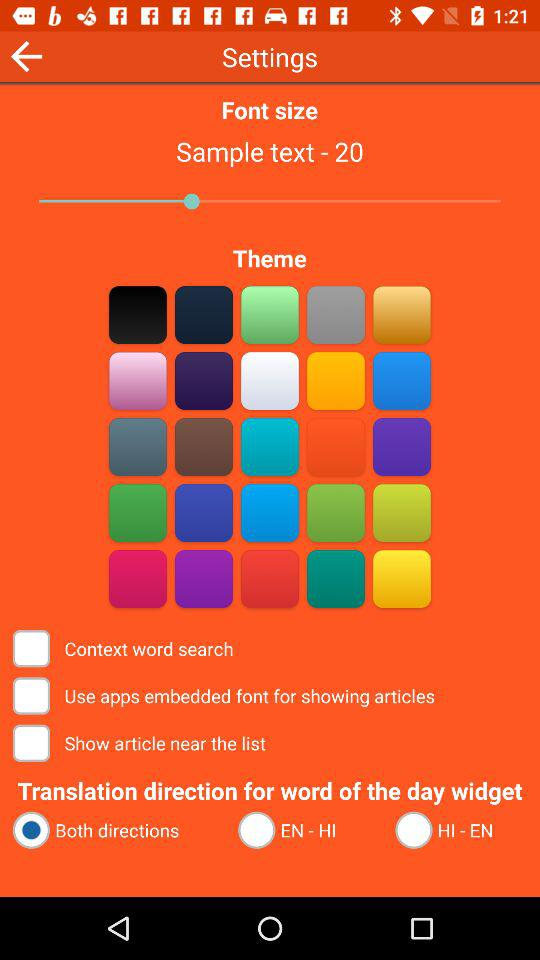What is the status of the "Context word search"? The status of the "Context word search" is "off". 